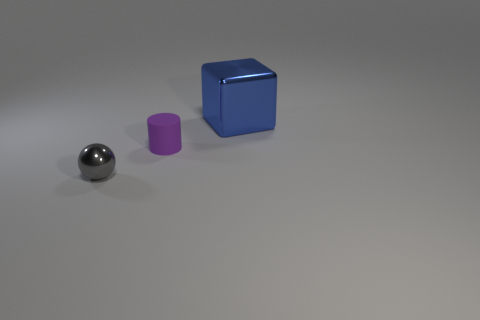What is the gray thing made of?
Give a very brief answer. Metal. The thing that is both behind the tiny gray shiny object and left of the large metallic object is made of what material?
Your answer should be compact. Rubber. How many things are either metal things that are behind the matte cylinder or gray shiny objects?
Provide a succinct answer. 2. Are there any blue objects of the same size as the gray object?
Provide a succinct answer. No. What number of metallic objects are both behind the small ball and in front of the large blue shiny object?
Your answer should be compact. 0. There is a matte cylinder; what number of shiny objects are right of it?
Keep it short and to the point. 1. Is there a tiny gray thing of the same shape as the blue metallic object?
Ensure brevity in your answer.  No. How many balls are small gray things or blue metallic objects?
Give a very brief answer. 1. There is a metallic thing that is on the left side of the blue object; what is its shape?
Your response must be concise. Sphere. What number of large blue objects are the same material as the ball?
Offer a very short reply. 1. 